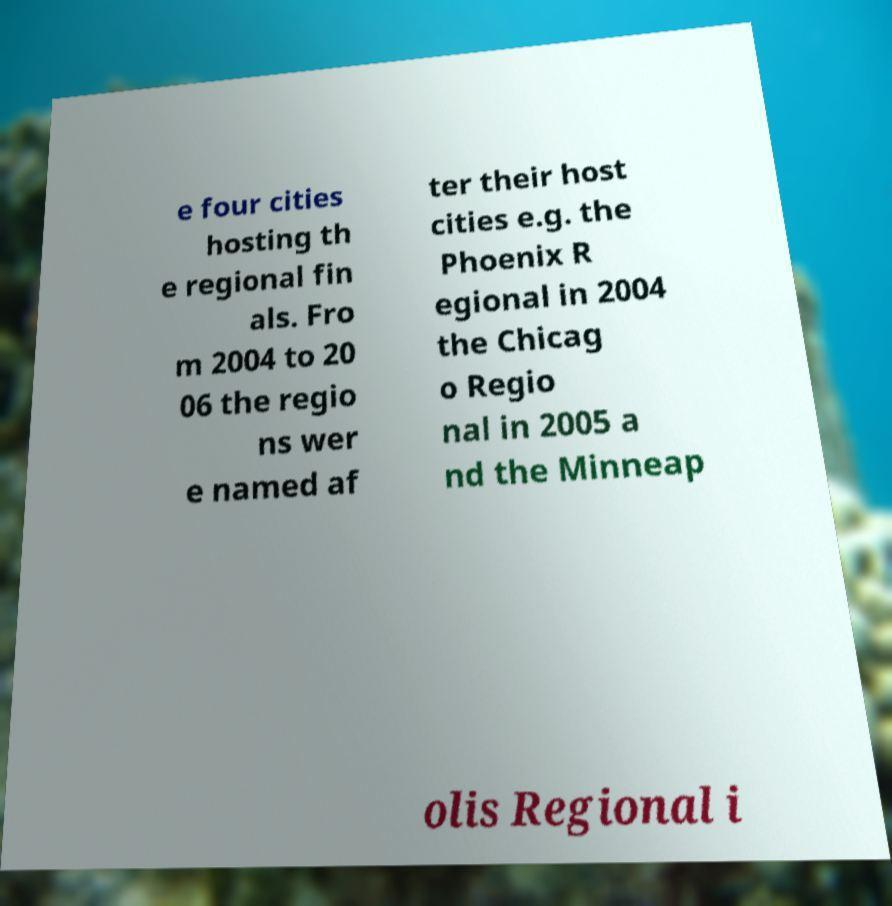For documentation purposes, I need the text within this image transcribed. Could you provide that? e four cities hosting th e regional fin als. Fro m 2004 to 20 06 the regio ns wer e named af ter their host cities e.g. the Phoenix R egional in 2004 the Chicag o Regio nal in 2005 a nd the Minneap olis Regional i 